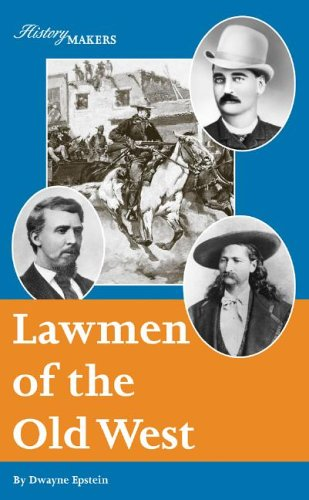What can you tell me about the historical period covered in this book? This book discusses the era of the Old West in America, focusing on the 19th century when lawmen played critical roles in maintaining order and justice in a rapidly expanding frontier society. 